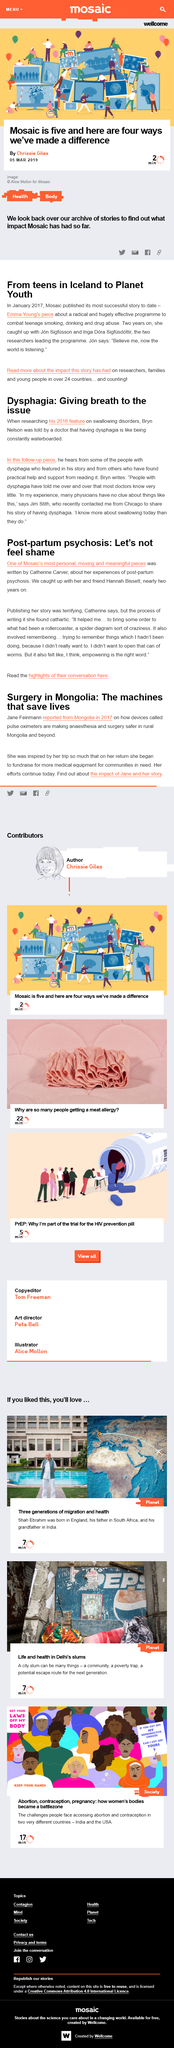Give some essential details in this illustration. Mosaic has made a difference in four distinct ways. The article's subject about which its publication was described as 'terrifying' by its author is post-partum psychosis. Chrissie Giles, the author of the article "Mosaic is five and here are four ways we've made a difference," wrote the article. Catherine Carver is the author of the piece on post-partum psychosis. On March 5th, 2019, the article "Mosaic is five and here are four ways we've made a difference" was published. 